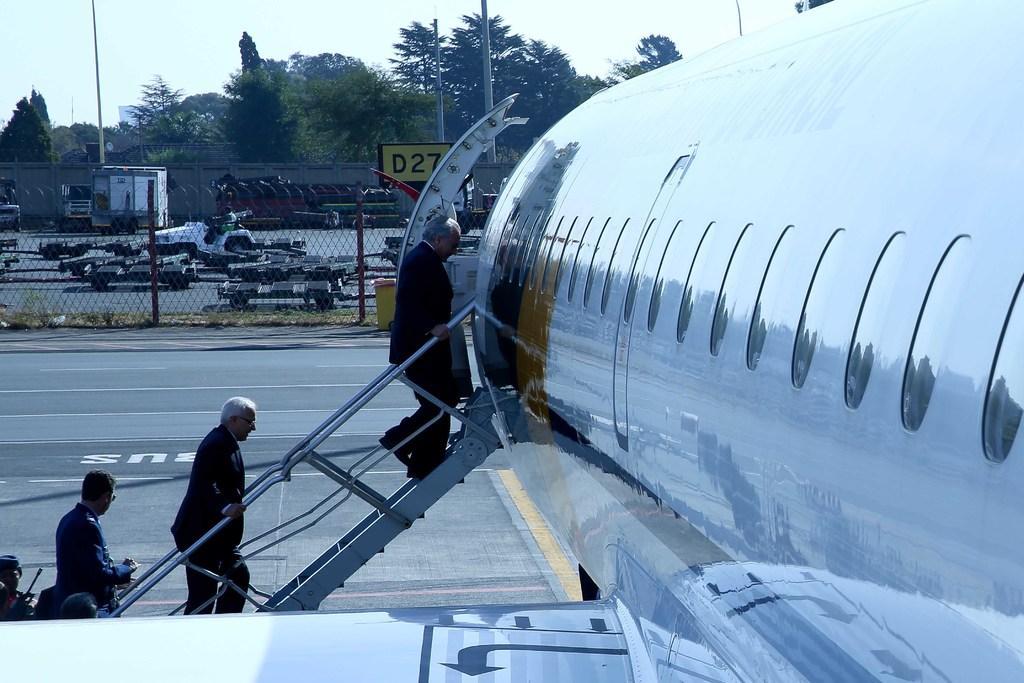Describe this image in one or two sentences. In this image I can see an airplane in the front and near it I can see few people are standing. I can also see stairs on the left side. In the background I can see a road, fencing, a board, few vehicles, number of trees, few poles, the sky and on the board I can see something is written. 